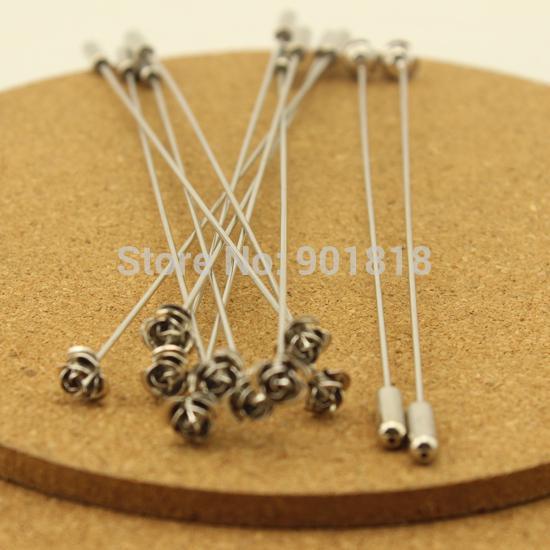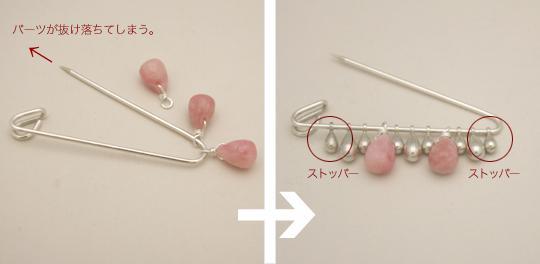The first image is the image on the left, the second image is the image on the right. Examine the images to the left and right. Is the description "The image to the left has a fabric background." accurate? Answer yes or no. No. 